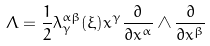Convert formula to latex. <formula><loc_0><loc_0><loc_500><loc_500>\Lambda = \frac { 1 } { 2 } \lambda _ { \gamma } ^ { \alpha \beta } ( \xi ) x ^ { \gamma } \frac { \partial } { \partial x ^ { \alpha } } \wedge \frac { \partial } { \partial x ^ { \beta } }</formula> 